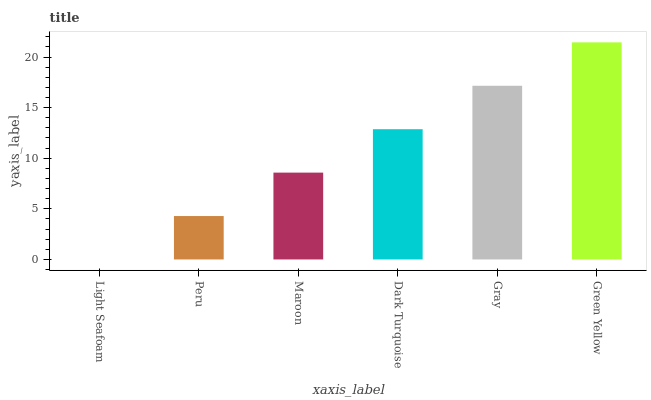Is Light Seafoam the minimum?
Answer yes or no. Yes. Is Green Yellow the maximum?
Answer yes or no. Yes. Is Peru the minimum?
Answer yes or no. No. Is Peru the maximum?
Answer yes or no. No. Is Peru greater than Light Seafoam?
Answer yes or no. Yes. Is Light Seafoam less than Peru?
Answer yes or no. Yes. Is Light Seafoam greater than Peru?
Answer yes or no. No. Is Peru less than Light Seafoam?
Answer yes or no. No. Is Dark Turquoise the high median?
Answer yes or no. Yes. Is Maroon the low median?
Answer yes or no. Yes. Is Green Yellow the high median?
Answer yes or no. No. Is Green Yellow the low median?
Answer yes or no. No. 